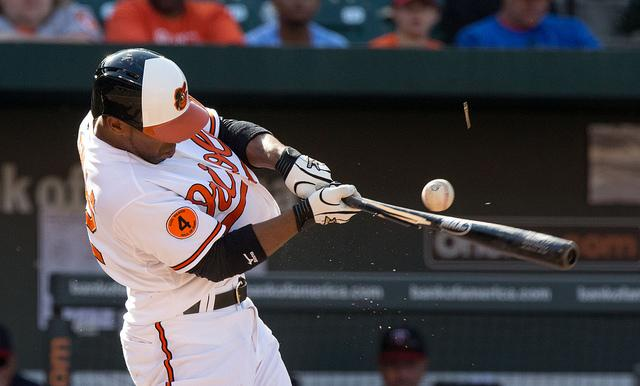Who got this ball to this place? pitcher 